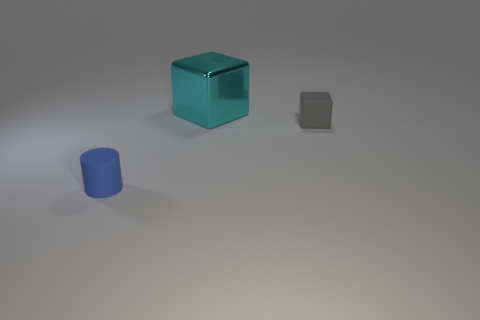Add 1 red blocks. How many objects exist? 4 Subtract 1 cylinders. How many cylinders are left? 0 Subtract all blocks. How many objects are left? 1 Add 1 small blue matte things. How many small blue matte things are left? 2 Add 3 big cyan objects. How many big cyan objects exist? 4 Subtract 0 yellow blocks. How many objects are left? 3 Subtract all gray blocks. Subtract all yellow cylinders. How many blocks are left? 1 Subtract all large brown matte objects. Subtract all shiny objects. How many objects are left? 2 